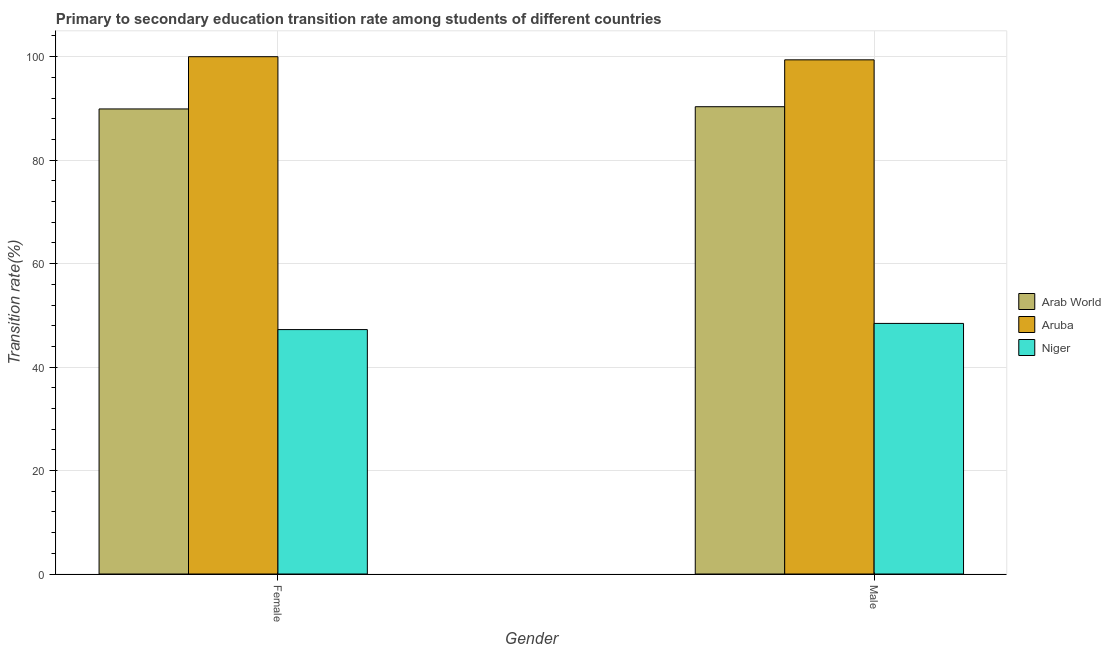How many bars are there on the 1st tick from the left?
Your answer should be compact. 3. What is the transition rate among female students in Niger?
Your answer should be very brief. 47.25. Across all countries, what is the maximum transition rate among female students?
Give a very brief answer. 100. Across all countries, what is the minimum transition rate among female students?
Your answer should be compact. 47.25. In which country was the transition rate among female students maximum?
Offer a very short reply. Aruba. In which country was the transition rate among male students minimum?
Provide a short and direct response. Niger. What is the total transition rate among male students in the graph?
Provide a short and direct response. 238.16. What is the difference between the transition rate among female students in Arab World and that in Aruba?
Make the answer very short. -10.1. What is the difference between the transition rate among male students in Niger and the transition rate among female students in Arab World?
Provide a succinct answer. -41.46. What is the average transition rate among male students per country?
Keep it short and to the point. 79.39. What is the difference between the transition rate among female students and transition rate among male students in Aruba?
Make the answer very short. 0.61. In how many countries, is the transition rate among male students greater than 40 %?
Keep it short and to the point. 3. What is the ratio of the transition rate among male students in Arab World to that in Niger?
Make the answer very short. 1.86. Is the transition rate among female students in Arab World less than that in Niger?
Offer a terse response. No. What does the 1st bar from the left in Female represents?
Your answer should be very brief. Arab World. What does the 2nd bar from the right in Female represents?
Make the answer very short. Aruba. How many bars are there?
Your answer should be compact. 6. Are all the bars in the graph horizontal?
Ensure brevity in your answer.  No. What is the difference between two consecutive major ticks on the Y-axis?
Offer a terse response. 20. Are the values on the major ticks of Y-axis written in scientific E-notation?
Keep it short and to the point. No. How many legend labels are there?
Your response must be concise. 3. What is the title of the graph?
Offer a terse response. Primary to secondary education transition rate among students of different countries. Does "Comoros" appear as one of the legend labels in the graph?
Offer a terse response. No. What is the label or title of the X-axis?
Your response must be concise. Gender. What is the label or title of the Y-axis?
Your answer should be compact. Transition rate(%). What is the Transition rate(%) in Arab World in Female?
Offer a very short reply. 89.9. What is the Transition rate(%) in Niger in Female?
Your answer should be very brief. 47.25. What is the Transition rate(%) in Arab World in Male?
Your answer should be very brief. 90.33. What is the Transition rate(%) in Aruba in Male?
Your response must be concise. 99.39. What is the Transition rate(%) of Niger in Male?
Keep it short and to the point. 48.44. Across all Gender, what is the maximum Transition rate(%) in Arab World?
Ensure brevity in your answer.  90.33. Across all Gender, what is the maximum Transition rate(%) of Aruba?
Provide a succinct answer. 100. Across all Gender, what is the maximum Transition rate(%) in Niger?
Offer a terse response. 48.44. Across all Gender, what is the minimum Transition rate(%) in Arab World?
Offer a very short reply. 89.9. Across all Gender, what is the minimum Transition rate(%) of Aruba?
Your answer should be very brief. 99.39. Across all Gender, what is the minimum Transition rate(%) in Niger?
Your answer should be compact. 47.25. What is the total Transition rate(%) in Arab World in the graph?
Offer a very short reply. 180.23. What is the total Transition rate(%) of Aruba in the graph?
Your answer should be compact. 199.39. What is the total Transition rate(%) in Niger in the graph?
Your answer should be very brief. 95.69. What is the difference between the Transition rate(%) in Arab World in Female and that in Male?
Make the answer very short. -0.43. What is the difference between the Transition rate(%) of Aruba in Female and that in Male?
Offer a very short reply. 0.61. What is the difference between the Transition rate(%) in Niger in Female and that in Male?
Provide a succinct answer. -1.19. What is the difference between the Transition rate(%) of Arab World in Female and the Transition rate(%) of Aruba in Male?
Offer a very short reply. -9.49. What is the difference between the Transition rate(%) in Arab World in Female and the Transition rate(%) in Niger in Male?
Offer a very short reply. 41.46. What is the difference between the Transition rate(%) in Aruba in Female and the Transition rate(%) in Niger in Male?
Keep it short and to the point. 51.56. What is the average Transition rate(%) in Arab World per Gender?
Keep it short and to the point. 90.11. What is the average Transition rate(%) in Aruba per Gender?
Make the answer very short. 99.7. What is the average Transition rate(%) in Niger per Gender?
Provide a succinct answer. 47.84. What is the difference between the Transition rate(%) in Arab World and Transition rate(%) in Aruba in Female?
Make the answer very short. -10.1. What is the difference between the Transition rate(%) of Arab World and Transition rate(%) of Niger in Female?
Give a very brief answer. 42.65. What is the difference between the Transition rate(%) of Aruba and Transition rate(%) of Niger in Female?
Provide a succinct answer. 52.75. What is the difference between the Transition rate(%) of Arab World and Transition rate(%) of Aruba in Male?
Make the answer very short. -9.06. What is the difference between the Transition rate(%) of Arab World and Transition rate(%) of Niger in Male?
Offer a very short reply. 41.89. What is the difference between the Transition rate(%) in Aruba and Transition rate(%) in Niger in Male?
Make the answer very short. 50.95. What is the ratio of the Transition rate(%) in Arab World in Female to that in Male?
Keep it short and to the point. 1. What is the ratio of the Transition rate(%) of Aruba in Female to that in Male?
Offer a very short reply. 1.01. What is the ratio of the Transition rate(%) in Niger in Female to that in Male?
Provide a short and direct response. 0.98. What is the difference between the highest and the second highest Transition rate(%) in Arab World?
Make the answer very short. 0.43. What is the difference between the highest and the second highest Transition rate(%) of Aruba?
Provide a succinct answer. 0.61. What is the difference between the highest and the second highest Transition rate(%) of Niger?
Provide a short and direct response. 1.19. What is the difference between the highest and the lowest Transition rate(%) in Arab World?
Make the answer very short. 0.43. What is the difference between the highest and the lowest Transition rate(%) in Aruba?
Your response must be concise. 0.61. What is the difference between the highest and the lowest Transition rate(%) of Niger?
Keep it short and to the point. 1.19. 